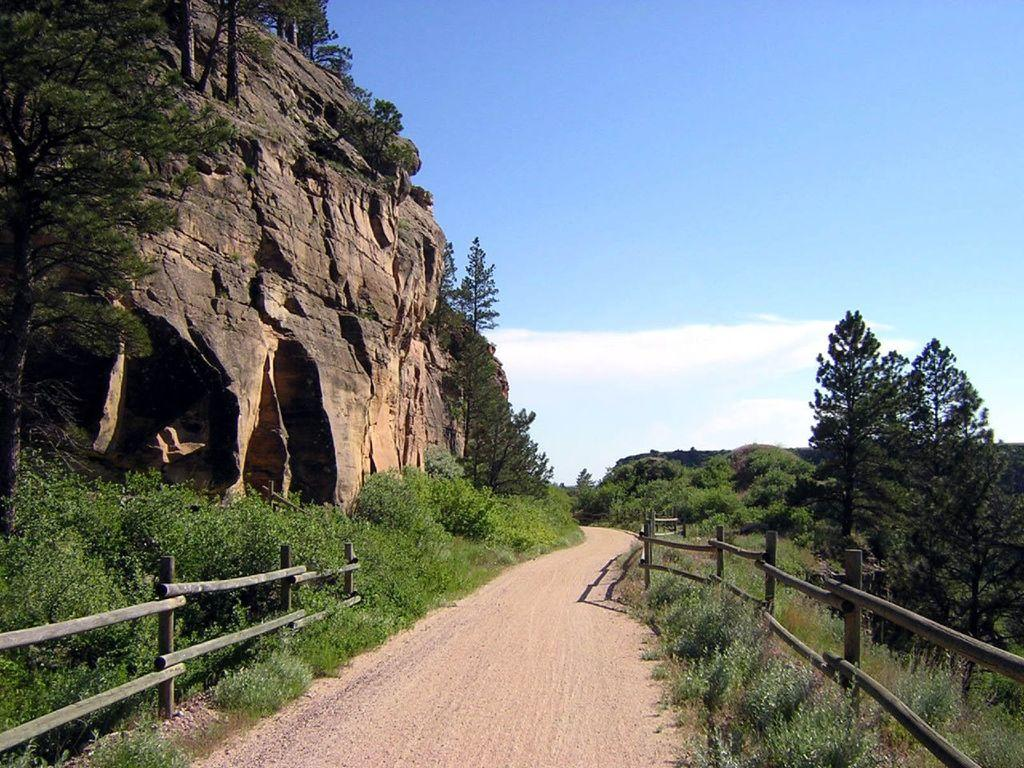What is the main feature of the image? There is a rock in the image. What other natural elements can be seen in the image? There are trees, plants, grass, and a cloudy, pale blue sky visible in the image. Are there any man-made structures in the image? Yes, there is a path and a wooden fence in the image. What grade of beans is being grown in the garden shown in the image? There is no garden or beans present in the image; it features a rock, trees, plants, grass, a path, and a wooden fence. 